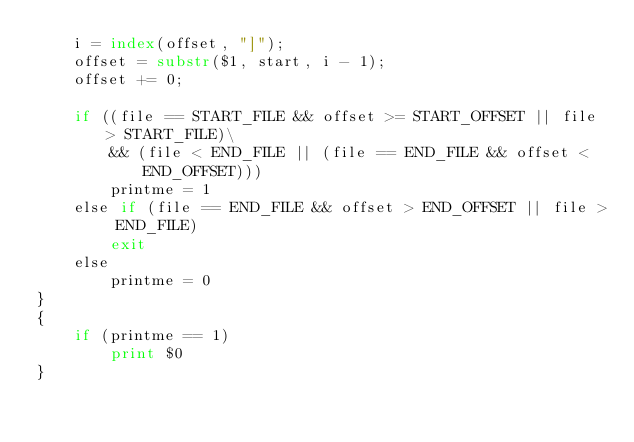Convert code to text. <code><loc_0><loc_0><loc_500><loc_500><_Awk_>	i = index(offset, "]");
	offset = substr($1, start, i - 1);
	offset += 0;

	if ((file == START_FILE && offset >= START_OFFSET || file > START_FILE)\
	    && (file < END_FILE || (file == END_FILE && offset < END_OFFSET)))
		printme = 1
	else if (file == END_FILE && offset > END_OFFSET || file > END_FILE)
		exit
	else
		printme = 0
}
{
	if (printme == 1)
		print $0
}
</code> 